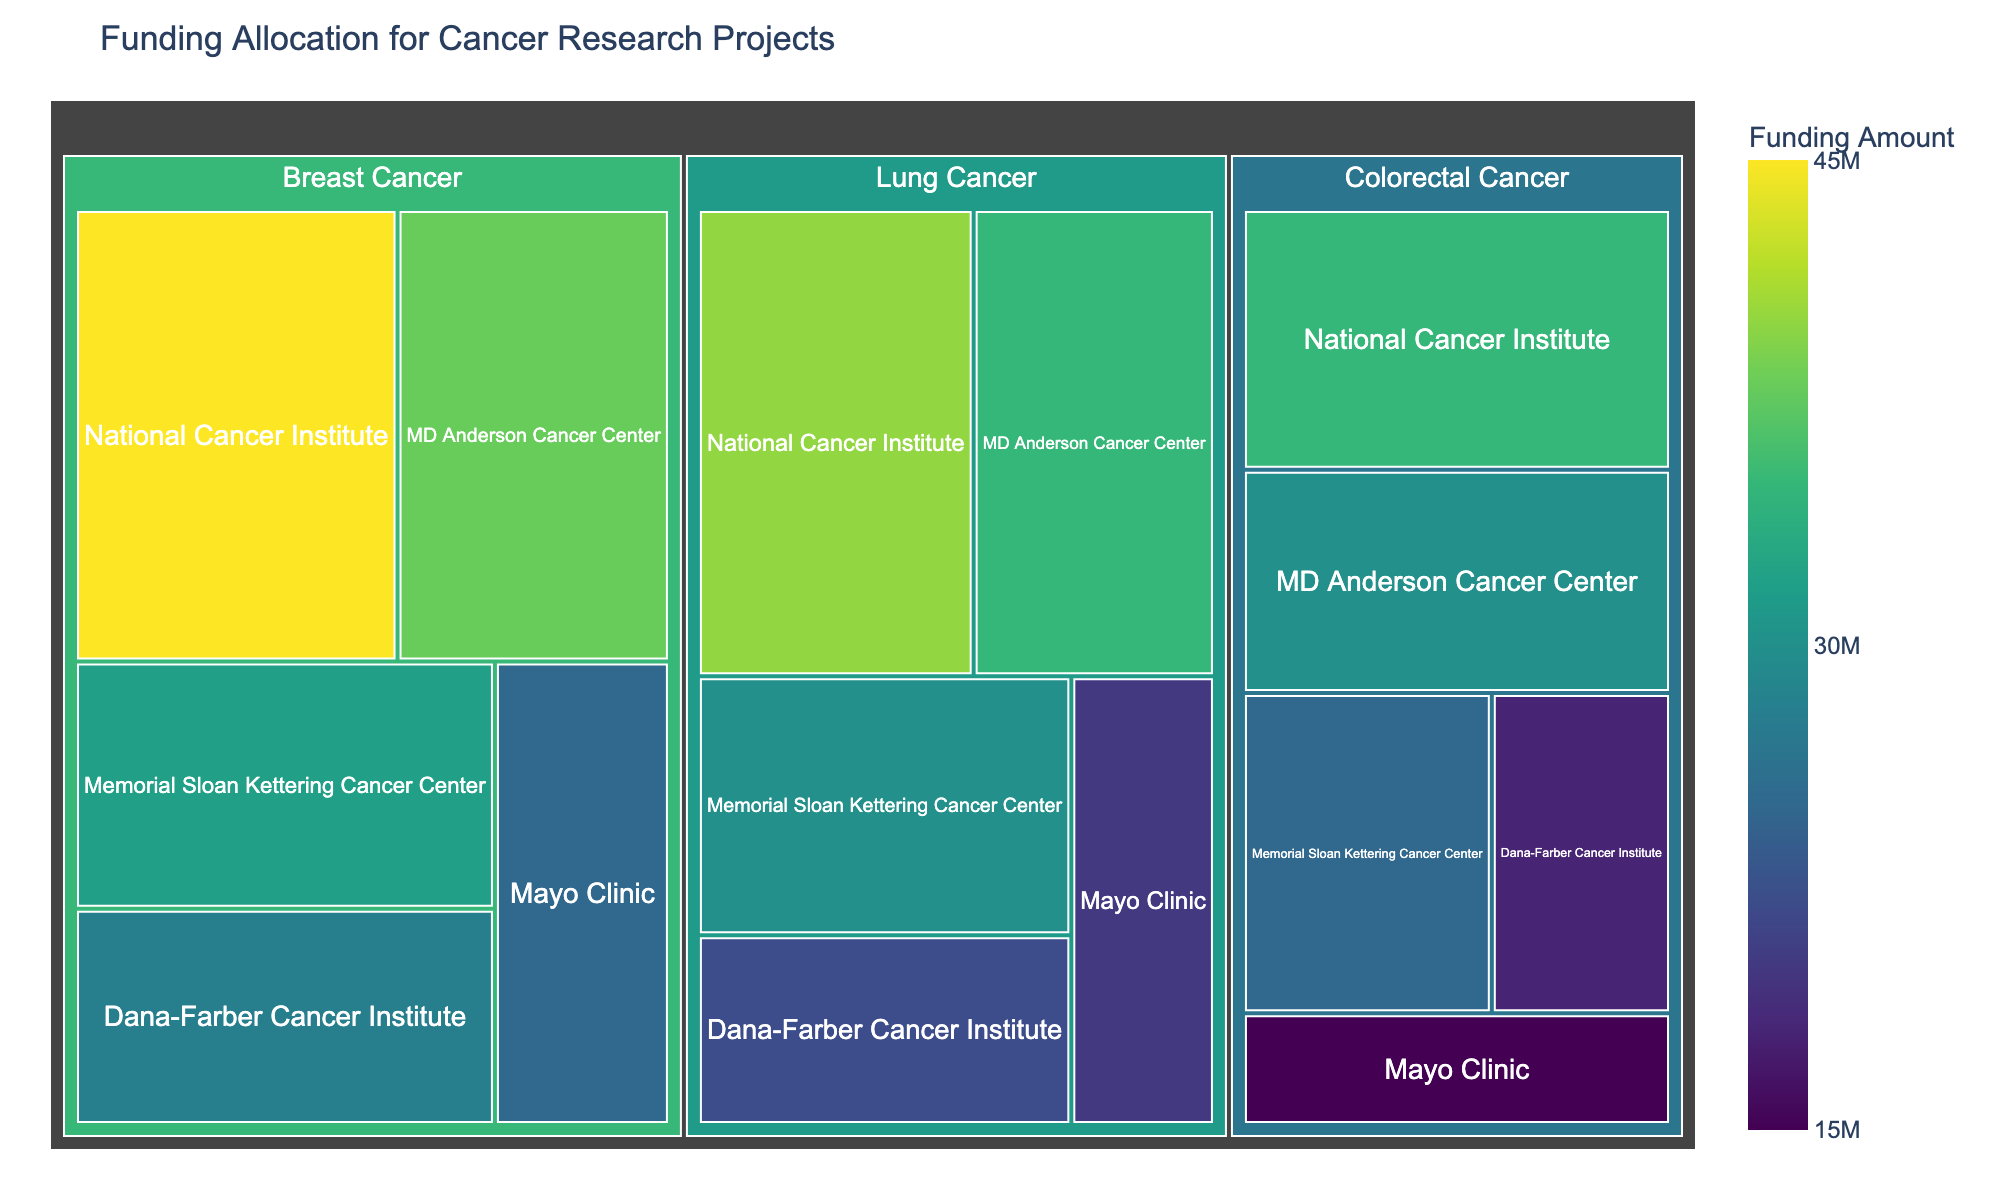How much funding was allocated to MD Anderson Cancer Center for breast cancer research? The treemap shows funding distributed across different institutions and research areas. Find MD Anderson Cancer Center under the "Breast Cancer" section and read the funding amount.
Answer: $38,000,000 Which research area received the highest total funding overall? Sum the funding amounts for all institutions within each research area and compare. Breast Cancer: $168,000,000, Lung Cancer: $147,000,000, Colorectal Cancer: $123,000,000.
Answer: Breast Cancer What is the difference in funding between National Cancer Institute and Mayo Clinic for lung cancer research? Locate the funding amounts for Lung Cancer at both institutions: National Cancer Institute ($40,000,000) and Mayo Clinic ($20,000,000). Subtract Mayo Clinic’s funding from National Cancer Institute’s.
Answer: $20,000,000 Which institution received the least funding for colorectal cancer research? Identify the funding allocations for colorectal cancer research across all institutions: National Cancer Institute ($35,000,000), Memorial Sloan Kettering Cancer Center ($25,000,000), MD Anderson Cancer Center ($30,000,000), Dana-Farber Cancer Institute ($18,000,000), Mayo Clinic ($15,000,000). Compare these amounts to find the minimum value.
Answer: Mayo Clinic Which institution has the most diverse funding across the three research areas? Count the number of research areas each institution received funding for and observe the distribution of funding amounts. Each institution appears to participate in all three research areas, but you would analyze if their funding is more evenly distributed. This may require a visual estimate based on the funding blocks' sizes and colors.
Answer: Each institution participates in all three areas (but more analysis needed for distribution evaluation) What's the average funding amount for lung cancer research across all institutions? Add the funding amounts for lung cancer research across all institutions: $40,000,000 + $30,000,000 + $35,000,000 + $22,000,000 + $20,000,000 = $147,000,000. Divide by the number of institutions (5).
Answer: $29,400,000 Compare the funding amounts for breast cancer and colorectal cancer at National Cancer Institute. Which research area received more? Identify the funding amounts for both research areas at National Cancer Institute. For breast cancer: $45,000,000. For colorectal cancer: $35,000,000. Compare these amounts.
Answer: Breast Cancer What's the total funding for Memorial Sloan Kettering Cancer Center across all research areas? Add the funding amounts for all research areas at Memorial Sloan Kettering Cancer Center: Breast Cancer ($32,000,000), Lung Cancer ($30,000,000), and Colorectal Cancer ($25,000,000).
Answer: $87,000,000 Which institution received the highest funding for breast cancer research? Check the funding amounts for breast cancer research at each institution: National Cancer Institute ($45,000,000), Memorial Sloan Kettering Cancer Center ($32,000,000), MD Anderson Cancer Center ($38,000,000), Dana-Farber Cancer Institute ($28,000,000), and Mayo Clinic ($25,000,000).
Answer: National Cancer Institute Explain the structure of the treemap and how to interpret it. A treemap visually represents hierarchical data as nested rectangles, with the size of each rectangle proportional to its value. In this case, the largest outer rectangles represent research areas, like breast cancer, lung cancer, and colorectal cancer. Each of these contains smaller rectangles for different institutions, colored and sized by their funding amounts, making it easy to compare funding allocations. Hovering over a rectangle shows detailed information like the institution name and exact funding amount.
Answer: Nested rectangles sized by funding amount 